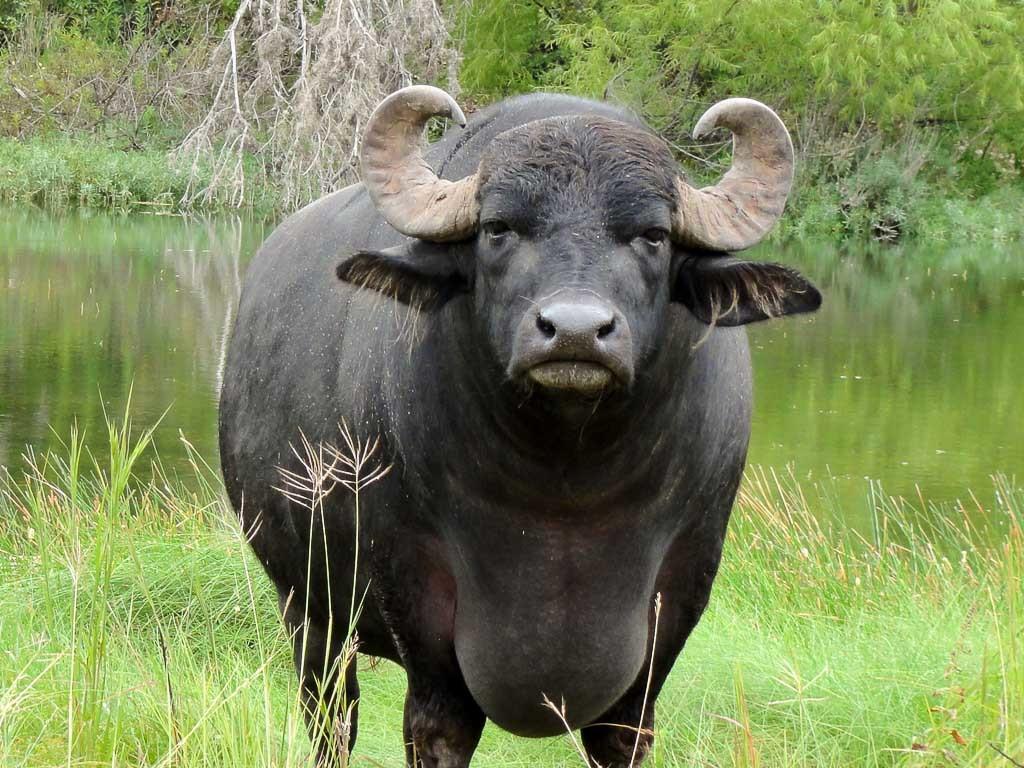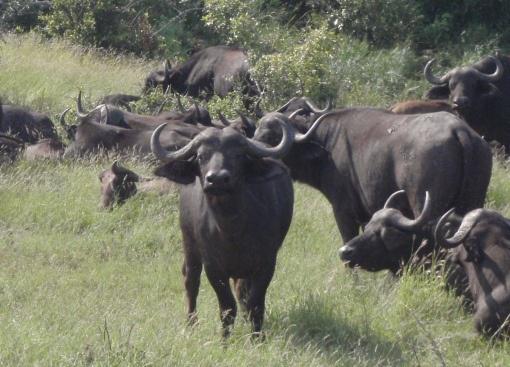The first image is the image on the left, the second image is the image on the right. Analyze the images presented: Is the assertion "One of the images contains more than one water buffalo." valid? Answer yes or no. Yes. 